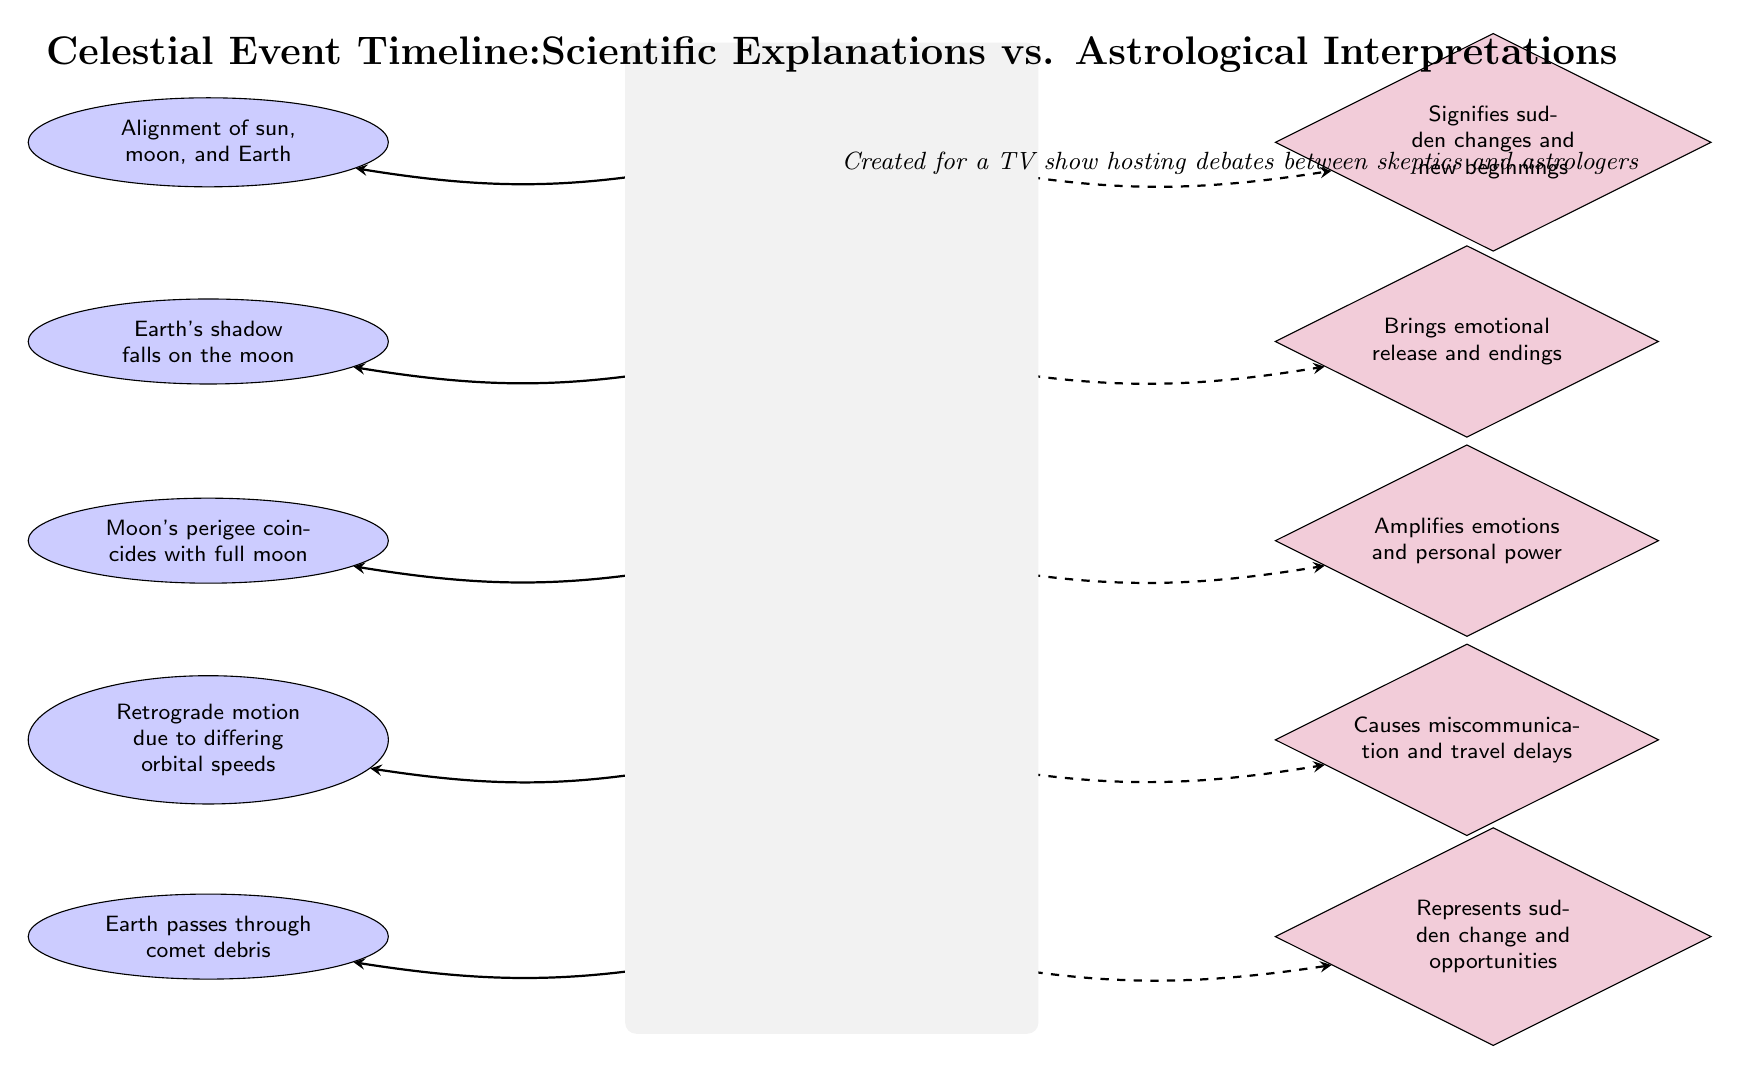What celestial event is associated with "sudden changes and new beginnings"? Referring to the diagram, the Solar Eclipse is linked to the astrological interpretation that signifies "sudden changes and new beginnings" through a dashed arrow.
Answer: Solar Eclipse How many celestial events are mentioned in the diagram? Counting vertically from the Solar Eclipse down to the Meteor Shower, there are five distinct celestial events shown in the diagram.
Answer: 5 What scientific explanation is given for Mercury Retrograde? The diagram states that the reason for Mercury Retrograde is "Retrograde motion due to differing orbital speeds," indicated in the ellipse next to the Mercury Retrograde event.
Answer: Retrograde motion due to differing orbital speeds What do meteor showers represent according to astrological interpretations? The diagram indicates that Meteor Showers are portrayed as representing "sudden change and opportunities" in the astrological interpretation, which can be read from the diamond shape next to Meteor Shower.
Answer: Sudden change and opportunities Which celestial event is associated with emotional release and endings? The Lunar Eclipse has an arrow pointing to the astrological interpretation that states it brings "emotional release and endings," thus identifying the event linked to that interpretation.
Answer: Lunar Eclipse How does the interpretation of a supermoon differ from its scientific explanation? The scientific explanation for Supermoon mentions "Moon's perigee coincides with full moon," while the astrological interpretation states that it "Amplifies emotions and personal power," showcasing a distinct difference in focus between the two sides.
Answer: Emotional amplification and personal power What is the relationship between solar eclipses and scientific explanations? The Solar Eclipse connects with the scientific explanation "Alignment of sun, moon, and Earth," as shown by the solid arrow indicating a direct relationship between the event and scientific rationale.
Answer: Alignment of sun, moon, and Earth In the diagram, what visual style represents astrological interpretations? Astrological interpretations are represented using a diamond shape filled with purple color, as exemplified by the nodes for each celestial event's astrological insights.
Answer: Diamond shape 